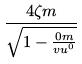Convert formula to latex. <formula><loc_0><loc_0><loc_500><loc_500>\frac { 4 \zeta m } { \sqrt { 1 - \frac { 0 m } { v u ^ { 0 } } } }</formula> 